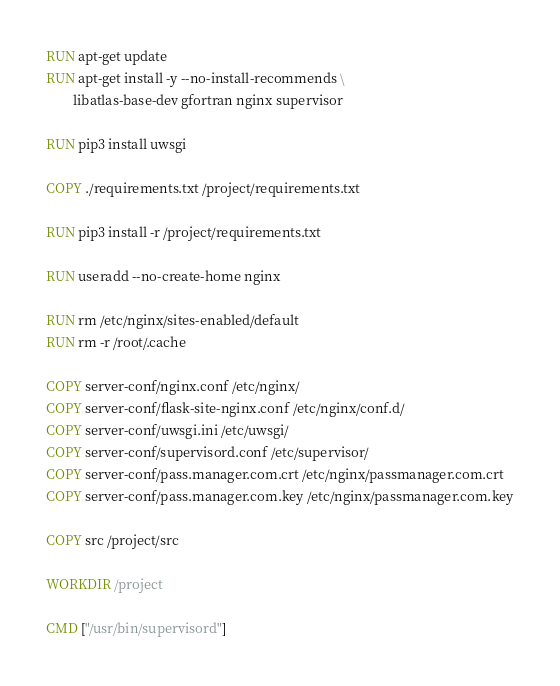Convert code to text. <code><loc_0><loc_0><loc_500><loc_500><_Dockerfile_>RUN apt-get update
RUN apt-get install -y --no-install-recommends \
        libatlas-base-dev gfortran nginx supervisor

RUN pip3 install uwsgi

COPY ./requirements.txt /project/requirements.txt

RUN pip3 install -r /project/requirements.txt

RUN useradd --no-create-home nginx

RUN rm /etc/nginx/sites-enabled/default
RUN rm -r /root/.cache

COPY server-conf/nginx.conf /etc/nginx/
COPY server-conf/flask-site-nginx.conf /etc/nginx/conf.d/
COPY server-conf/uwsgi.ini /etc/uwsgi/
COPY server-conf/supervisord.conf /etc/supervisor/
COPY server-conf/pass.manager.com.crt /etc/nginx/passmanager.com.crt
COPY server-conf/pass.manager.com.key /etc/nginx/passmanager.com.key

COPY src /project/src

WORKDIR /project

CMD ["/usr/bin/supervisord"]
</code> 